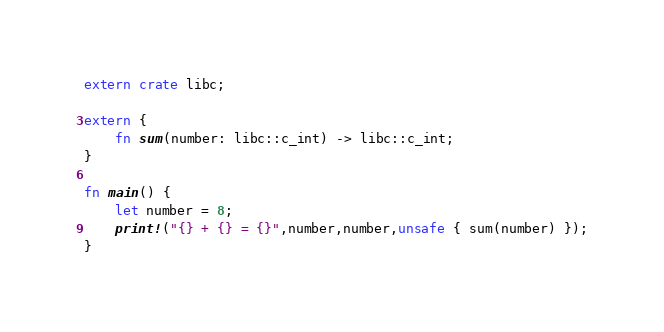<code> <loc_0><loc_0><loc_500><loc_500><_Rust_>extern crate libc;

extern {
    fn sum(number: libc::c_int) -> libc::c_int;
}

fn main() {
    let number = 8;
    print!("{} + {} = {}",number,number,unsafe { sum(number) });
}</code> 